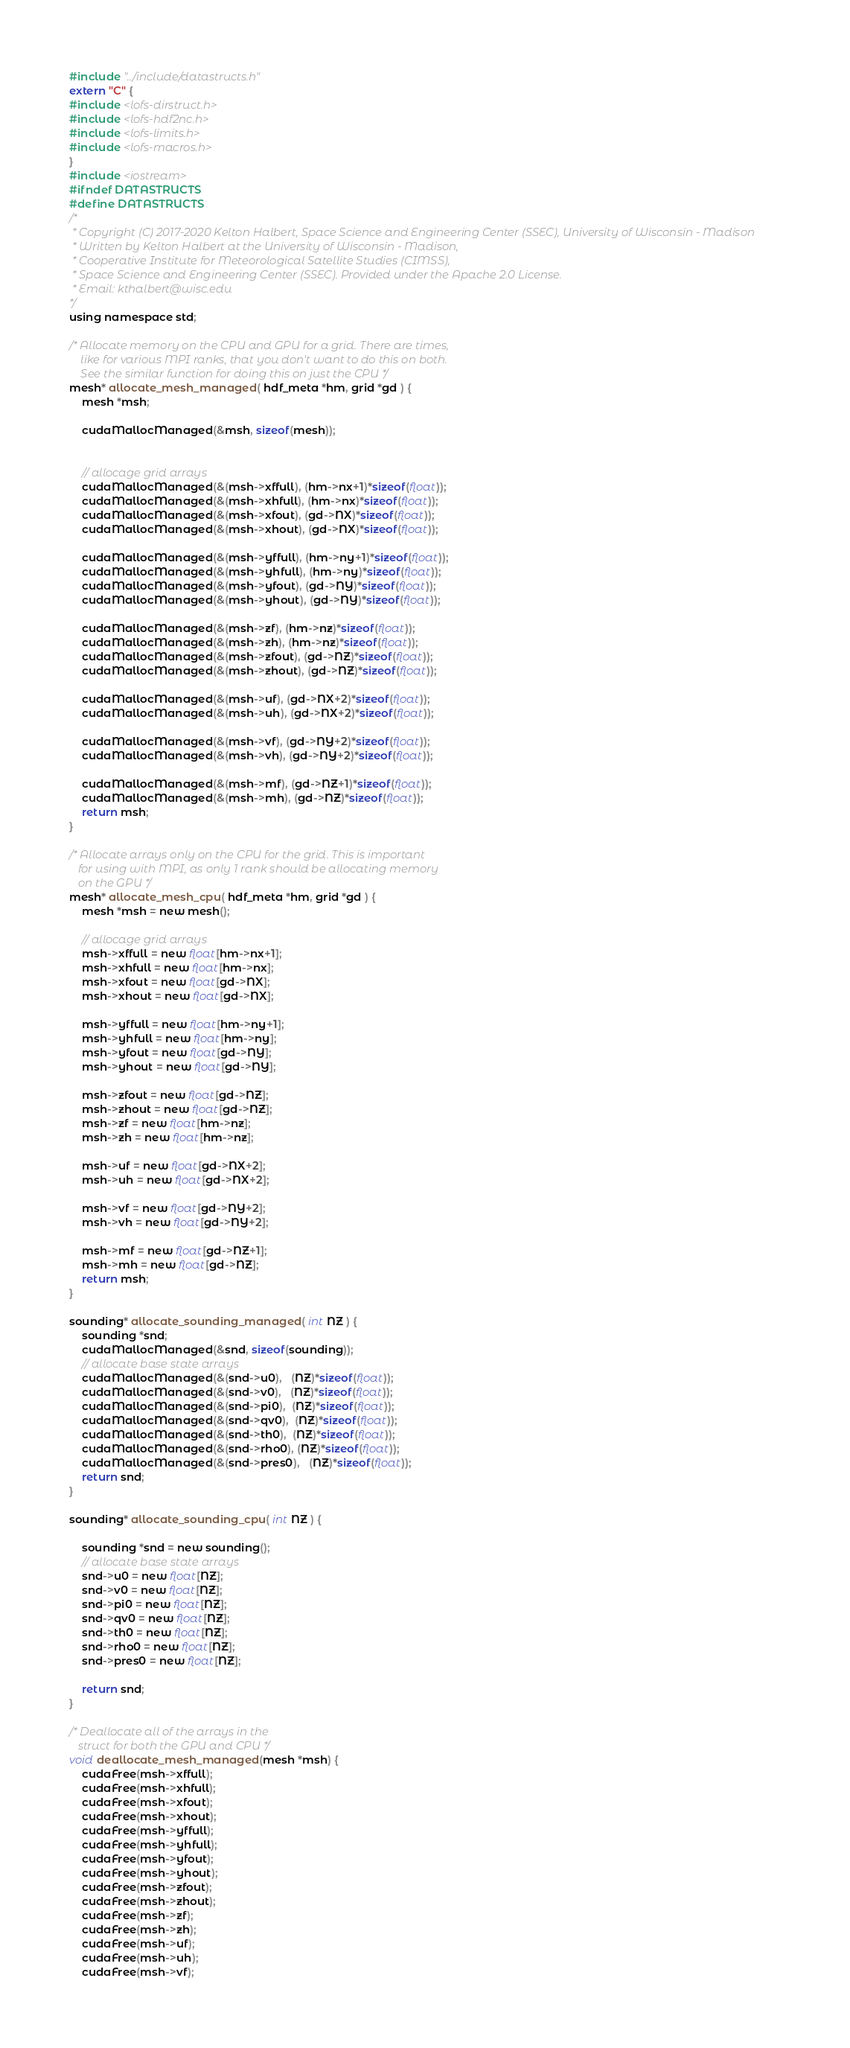Convert code to text. <code><loc_0><loc_0><loc_500><loc_500><_Cuda_>#include "../include/datastructs.h"
extern "C" {
#include <lofs-dirstruct.h>
#include <lofs-hdf2nc.h>
#include <lofs-limits.h>
#include <lofs-macros.h>
}
#include <iostream>
#ifndef DATASTRUCTS
#define DATASTRUCTS
/*
 * Copyright (C) 2017-2020 Kelton Halbert, Space Science and Engineering Center (SSEC), University of Wisconsin - Madison
 * Written by Kelton Halbert at the University of Wisconsin - Madison,
 * Cooperative Institute for Meteorological Satellite Studies (CIMSS),
 * Space Science and Engineering Center (SSEC). Provided under the Apache 2.0 License.
 * Email: kthalbert@wisc.edu
*/
using namespace std;

/* Allocate memory on the CPU and GPU for a grid. There are times,
    like for various MPI ranks, that you don't want to do this on both.
    See the similar function for doing this on just the CPU */
mesh* allocate_mesh_managed( hdf_meta *hm, grid *gd ) { 
    mesh *msh;

    cudaMallocManaged(&msh, sizeof(mesh));


    // allocage grid arrays
    cudaMallocManaged(&(msh->xffull), (hm->nx+1)*sizeof(float));
    cudaMallocManaged(&(msh->xhfull), (hm->nx)*sizeof(float));
    cudaMallocManaged(&(msh->xfout), (gd->NX)*sizeof(float));
    cudaMallocManaged(&(msh->xhout), (gd->NX)*sizeof(float));

    cudaMallocManaged(&(msh->yffull), (hm->ny+1)*sizeof(float));
    cudaMallocManaged(&(msh->yhfull), (hm->ny)*sizeof(float));
    cudaMallocManaged(&(msh->yfout), (gd->NY)*sizeof(float));
    cudaMallocManaged(&(msh->yhout), (gd->NY)*sizeof(float));

    cudaMallocManaged(&(msh->zf), (hm->nz)*sizeof(float));
    cudaMallocManaged(&(msh->zh), (hm->nz)*sizeof(float));
    cudaMallocManaged(&(msh->zfout), (gd->NZ)*sizeof(float));
    cudaMallocManaged(&(msh->zhout), (gd->NZ)*sizeof(float));

    cudaMallocManaged(&(msh->uf), (gd->NX+2)*sizeof(float));
    cudaMallocManaged(&(msh->uh), (gd->NX+2)*sizeof(float));

    cudaMallocManaged(&(msh->vf), (gd->NY+2)*sizeof(float));
    cudaMallocManaged(&(msh->vh), (gd->NY+2)*sizeof(float));

    cudaMallocManaged(&(msh->mf), (gd->NZ+1)*sizeof(float));
    cudaMallocManaged(&(msh->mh), (gd->NZ)*sizeof(float));
    return msh;
}

/* Allocate arrays only on the CPU for the grid. This is important
   for using with MPI, as only 1 rank should be allocating memory
   on the GPU */
mesh* allocate_mesh_cpu( hdf_meta *hm, grid *gd ) { 
    mesh *msh = new mesh();

    // allocage grid arrays
    msh->xffull = new float[hm->nx+1];
    msh->xhfull = new float[hm->nx];
    msh->xfout = new float[gd->NX];
    msh->xhout = new float[gd->NX];

    msh->yffull = new float[hm->ny+1];
    msh->yhfull = new float[hm->ny];
    msh->yfout = new float[gd->NY];
    msh->yhout = new float[gd->NY];

    msh->zfout = new float[gd->NZ];
    msh->zhout = new float[gd->NZ];
    msh->zf = new float[hm->nz];
    msh->zh = new float[hm->nz];

    msh->uf = new float[gd->NX+2];
    msh->uh = new float[gd->NX+2];

    msh->vf = new float[gd->NY+2];
    msh->vh = new float[gd->NY+2];

    msh->mf = new float[gd->NZ+1];
    msh->mh = new float[gd->NZ];
	return msh;
}

sounding* allocate_sounding_managed( int NZ ) {
	sounding *snd;
    cudaMallocManaged(&snd, sizeof(sounding));
    // allocate base state arrays
    cudaMallocManaged(&(snd->u0),   (NZ)*sizeof(float));
    cudaMallocManaged(&(snd->v0),   (NZ)*sizeof(float));
    cudaMallocManaged(&(snd->pi0),  (NZ)*sizeof(float));
    cudaMallocManaged(&(snd->qv0),  (NZ)*sizeof(float));
    cudaMallocManaged(&(snd->th0),  (NZ)*sizeof(float));
    cudaMallocManaged(&(snd->rho0), (NZ)*sizeof(float));
    cudaMallocManaged(&(snd->pres0),   (NZ)*sizeof(float));
	return snd;
}

sounding* allocate_sounding_cpu( int NZ ) {

	sounding *snd = new sounding();
    // allocate base state arrays
    snd->u0 = new float[NZ];
    snd->v0 = new float[NZ];
    snd->pi0 = new float[NZ];
    snd->qv0 = new float[NZ];
    snd->th0 = new float[NZ];
    snd->rho0 = new float[NZ];
    snd->pres0 = new float[NZ];

    return snd;
}

/* Deallocate all of the arrays in the 
   struct for both the GPU and CPU */
void deallocate_mesh_managed(mesh *msh) {
    cudaFree(msh->xffull);
    cudaFree(msh->xhfull);
    cudaFree(msh->xfout);
    cudaFree(msh->xhout);
    cudaFree(msh->yffull);
    cudaFree(msh->yhfull);
    cudaFree(msh->yfout);
    cudaFree(msh->yhout);
    cudaFree(msh->zfout);
    cudaFree(msh->zhout);
    cudaFree(msh->zf);
    cudaFree(msh->zh);
    cudaFree(msh->uf);
    cudaFree(msh->uh);
    cudaFree(msh->vf);</code> 